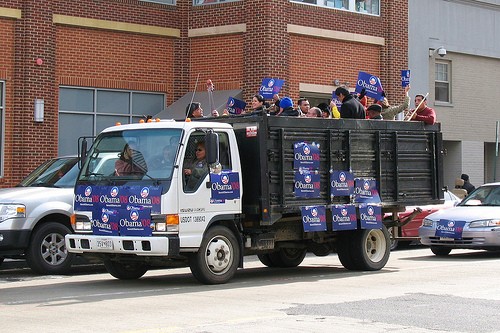Please provide a short description for this region: [0.12, 0.64, 0.35, 0.68]. The white bumper of the truck is visible. 